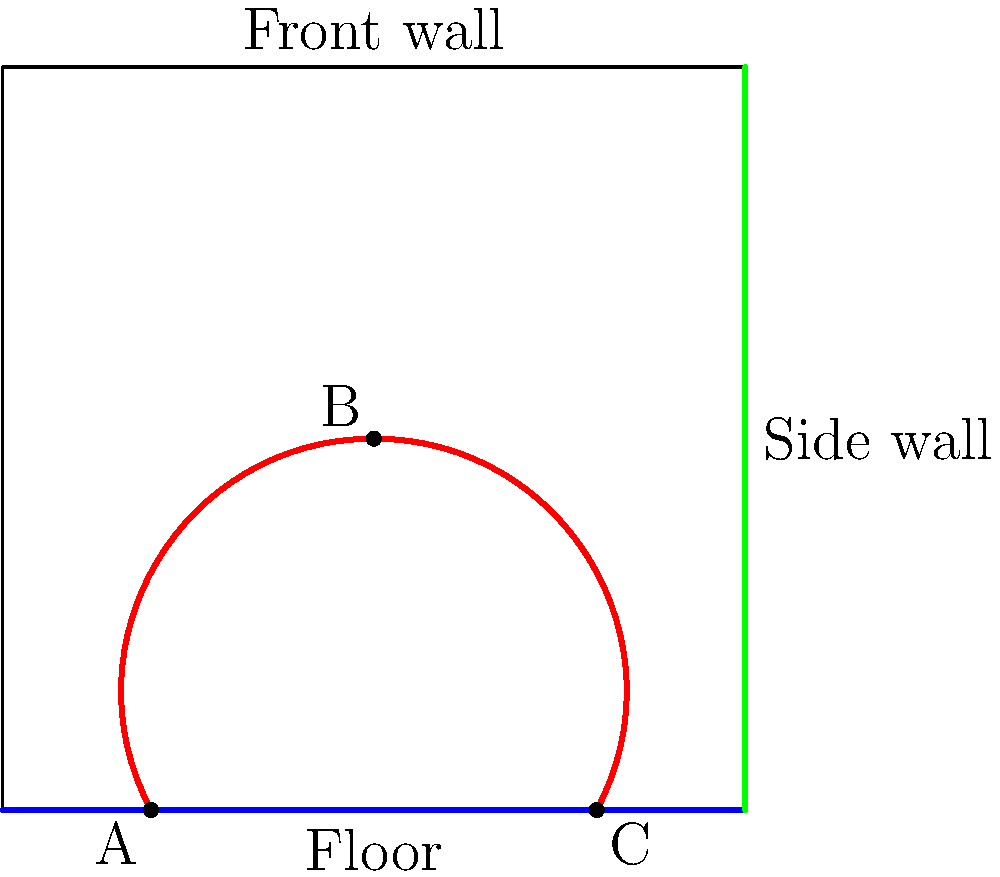In a professional squash match featuring Nardine Garas, the ball follows the trajectory shown in red. If the ball continues its path after point C with the same angle of reflection as it had when bouncing off the floor at point A, which wall will it hit next? To solve this problem, we need to analyze the trajectory of the squash ball and apply the law of reflection. Let's break it down step-by-step:

1. The ball starts at point A on the floor and travels to point B on the front wall.
2. It then reflects off the front wall and travels to point C on the floor.
3. The question asks about the ball's path after point C, assuming it follows the same angle of reflection as it did at point A.

To determine this:

4. Observe the angle of incidence at point A. The ball approaches the floor at this angle and then bounces up towards point B.
5. According to the law of reflection, the angle of incidence equals the angle of reflection when a ball bounces off a surface.
6. At point C, we need to imagine the ball bouncing up with the same angle as it did at point A, but in the opposite direction.
7. Looking at the trajectory, we can see that this angle would direct the ball towards the side wall (green line) rather than the front wall (blue line).

In professional squash, players like Nardine Garas often use these angled shots to make it difficult for their opponents to return the ball. This type of shot that hits the side wall after bouncing off the floor is commonly known as a "rail" or "straight drive" in squash terminology.
Answer: Side wall 